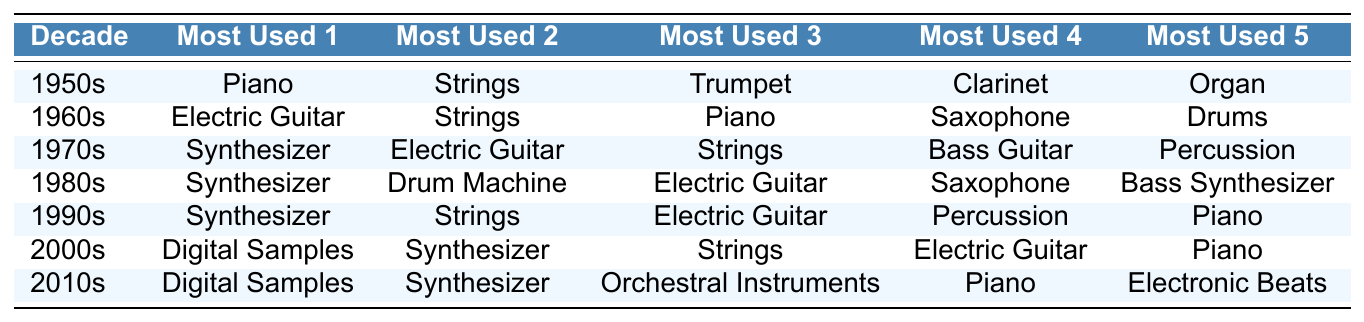What is the most used instrument in TV scores during the 1960s? According to the table, the "Most Used Instrument 1" for the 1960s is "Electric Guitar".
Answer: Electric Guitar Which decade primarily featured the Synthesizer as a major instrument? The table shows that Synthesizer is listed as the most used instrument for the 1970s, 1980s, 1990s, and 2000s. This indicates that the Synthesizer was primarily featured in the decades of the 1970s to the 2000s.
Answer: 1970s to 2000s Out of the 2010s, which instrument appears last in the ranking? In the 2010s, the instruments are listed as Digital Samples, Synthesizer, Orchestral Instruments, Piano, and Electronic Beats. The last instrument in this ranking is Electronic Beats.
Answer: Electronic Beats Did the Piano appear in more decades than the Clarinet? The Piano appears in the 1950s, 1960s, 1990s, 2000s, and 2010s, totaling 5 decades. The Clarinet only appears in the 1950s, totaling 1 decade. Since 5 is greater than 1, the answer is yes.
Answer: Yes What is the average position of the Electric Guitar in the decades it appears? The Electric Guitar appears in the 1960s (position 3), 1970s (position 2), 1980s (position 3), 1990s (position 3), and 2000s (position 4). Adding: 3 + 2 + 3 + 3 + 4 = 15. There are 5 appearances, so the average position is 15/5 = 3.
Answer: 3 Which instruments were consistently among the most used in each decade? By examining the table, we can see that while instruments like Synthesizer and Electric Guitar appear frequently, nothing is listed in all decades. Therefore, no instruments were consistently among the most used in every decade.
Answer: No instruments consistently In how many decades did Digital Samples appear and where? Digital Samples appeared in the 2000s and the 2010s, totaling 2 decades. They are ranked as the most used in both decades.
Answer: 2 decades Was the Trumpet ever the most used instrument in any decade? Referring to the table, the Trumpet appears only in the 1950s as the 3rd most used instrument, so it was never the most used instrument in any decade.
Answer: No If we consider the top instrument lists, which one changed most significantly after the 1970s? The change from Synthesizers and Electric Guitars in the 1970s to a more digital sound with Digital Samples in the 2000s represents a significant shift in instrumentation trends in TV scores.
Answer: Digital Samples in the 2000s 